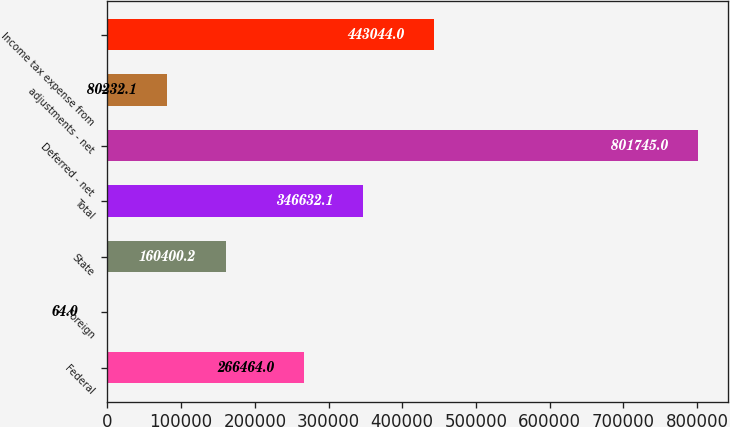Convert chart. <chart><loc_0><loc_0><loc_500><loc_500><bar_chart><fcel>Federal<fcel>Foreign<fcel>State<fcel>Total<fcel>Deferred - net<fcel>adjustments - net<fcel>Income tax expense from<nl><fcel>266464<fcel>64<fcel>160400<fcel>346632<fcel>801745<fcel>80232.1<fcel>443044<nl></chart> 